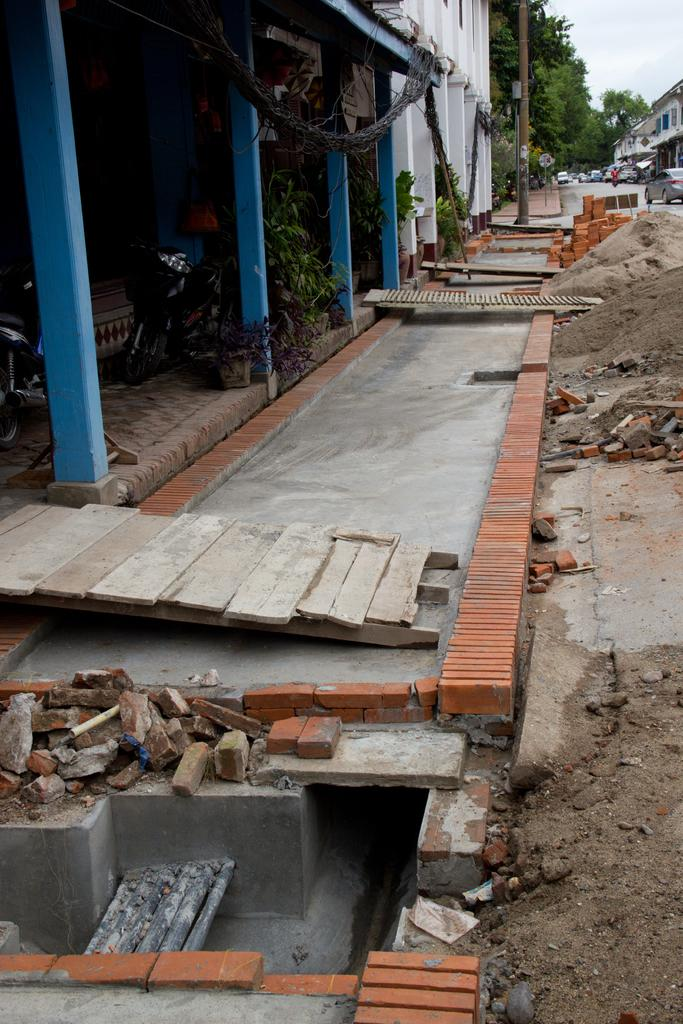What type of material is visible in the image? There are wooden planks in the image. What natural element is present in the image? There is sand in the image. What construction material can be seen in the image? There are bricks in the image. What type of vegetation is present in the image? There are plants in the image. What architectural feature is visible in the image? There are pillars in the image. What can be seen in the background of the image? In the background, there are buildings, a pole, trees, and vehicles. What part of the natural environment is visible in the background? The sky is visible in the background. How many geese are visible in the image? There are no geese present in the image. Where is the cellar located in the image? There is no cellar present in the image. What type of trains can be seen in the image? There are no trains present in the image. 